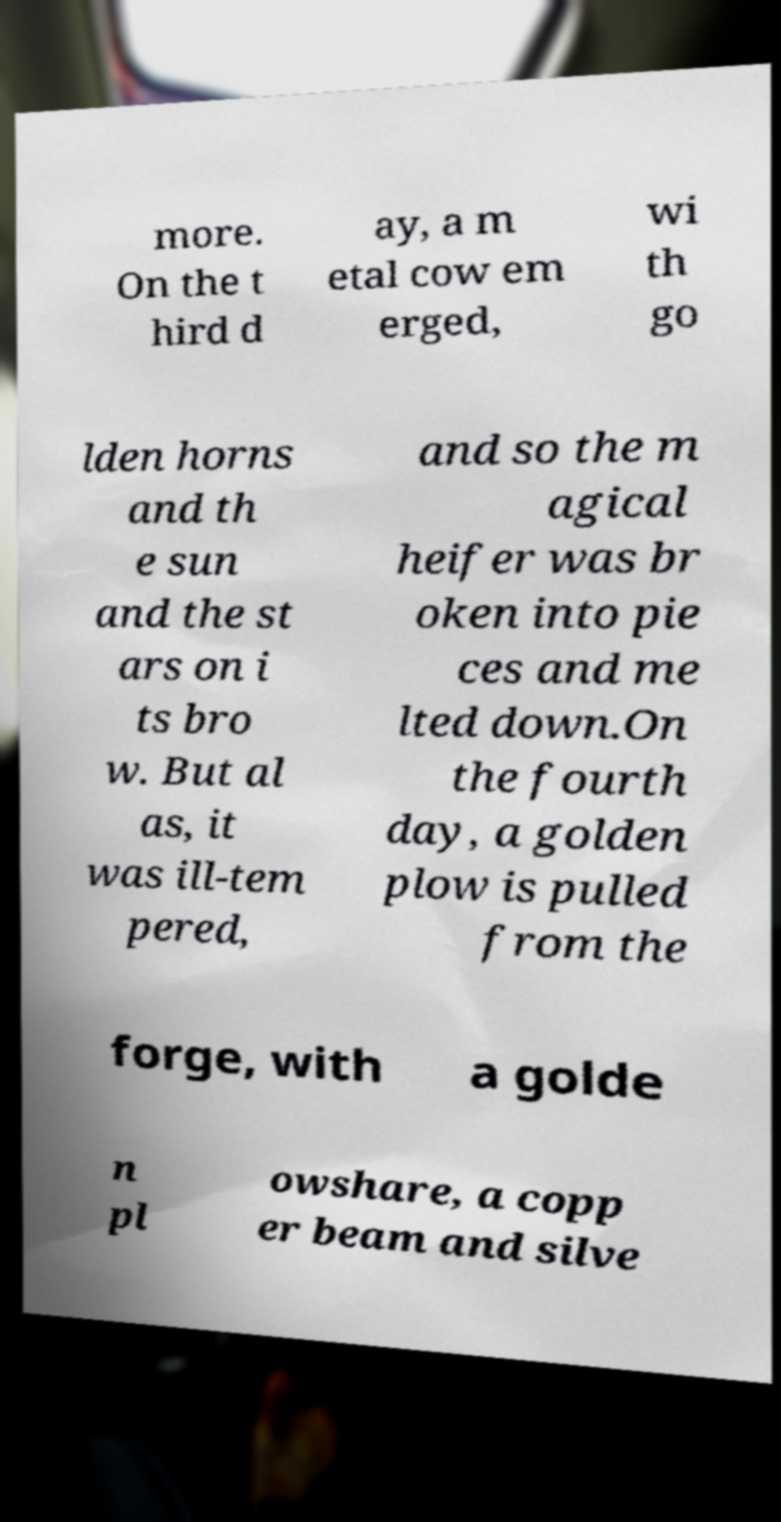For documentation purposes, I need the text within this image transcribed. Could you provide that? more. On the t hird d ay, a m etal cow em erged, wi th go lden horns and th e sun and the st ars on i ts bro w. But al as, it was ill-tem pered, and so the m agical heifer was br oken into pie ces and me lted down.On the fourth day, a golden plow is pulled from the forge, with a golde n pl owshare, a copp er beam and silve 